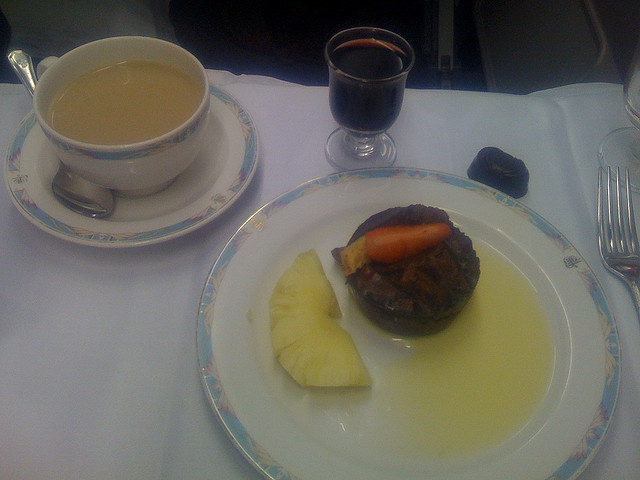Describe the objects in this image and their specific colors. I can see dining table in gray and black tones, cup in black, gray, and olive tones, cake in black, maroon, and brown tones, bowl in black, maroon, and brown tones, and wine glass in black and gray tones in this image. 